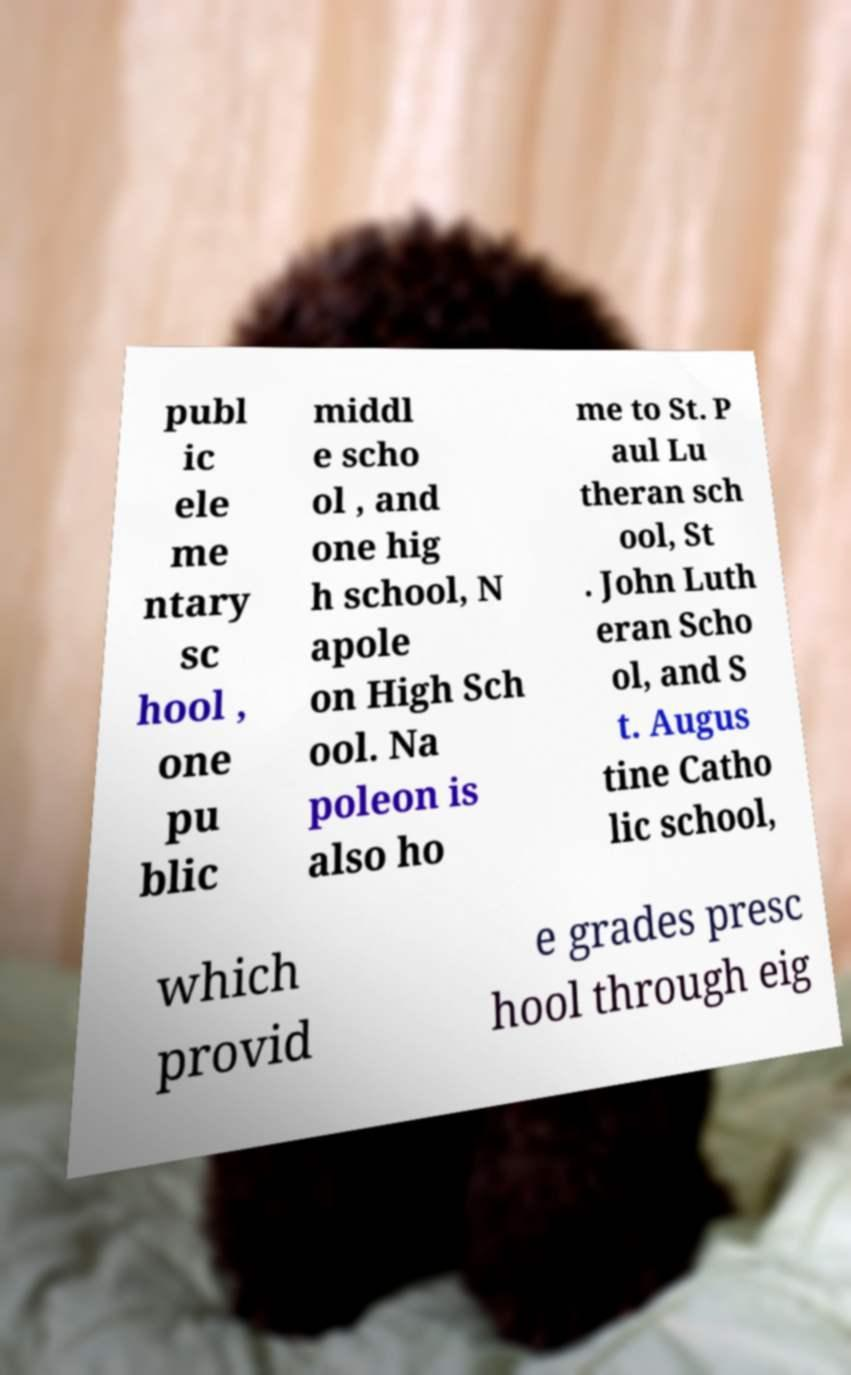Please read and relay the text visible in this image. What does it say? publ ic ele me ntary sc hool , one pu blic middl e scho ol , and one hig h school, N apole on High Sch ool. Na poleon is also ho me to St. P aul Lu theran sch ool, St . John Luth eran Scho ol, and S t. Augus tine Catho lic school, which provid e grades presc hool through eig 